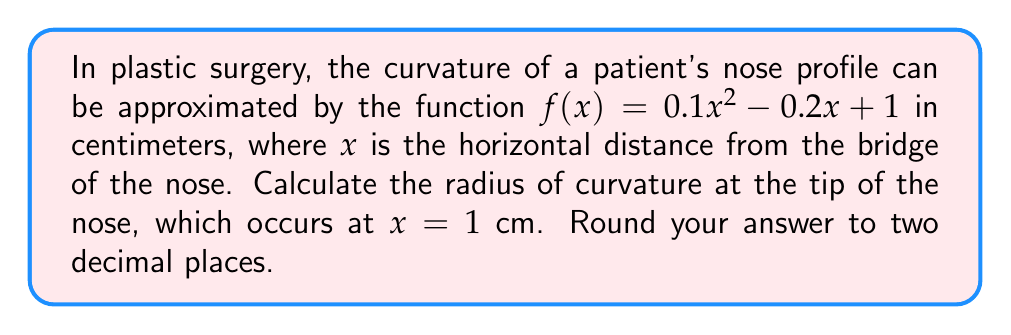Solve this math problem. To find the radius of curvature, we'll use the formula:

$$R = \frac{(1 + (f'(x))^2)^{3/2}}{|f''(x)|}$$

Step 1: Find $f'(x)$ and $f''(x)$
$f'(x) = 0.2x - 0.2$
$f''(x) = 0.2$

Step 2: Evaluate $f'(x)$ at $x = 1$
$f'(1) = 0.2(1) - 0.2 = 0$

Step 3: Substitute values into the radius of curvature formula
$$R = \frac{(1 + (0)^2)^{3/2}}{|0.2|}$$

Step 4: Simplify
$$R = \frac{1}{0.2} = 5$$

Therefore, the radius of curvature at the tip of the nose is 5 cm.
Answer: 5.00 cm 